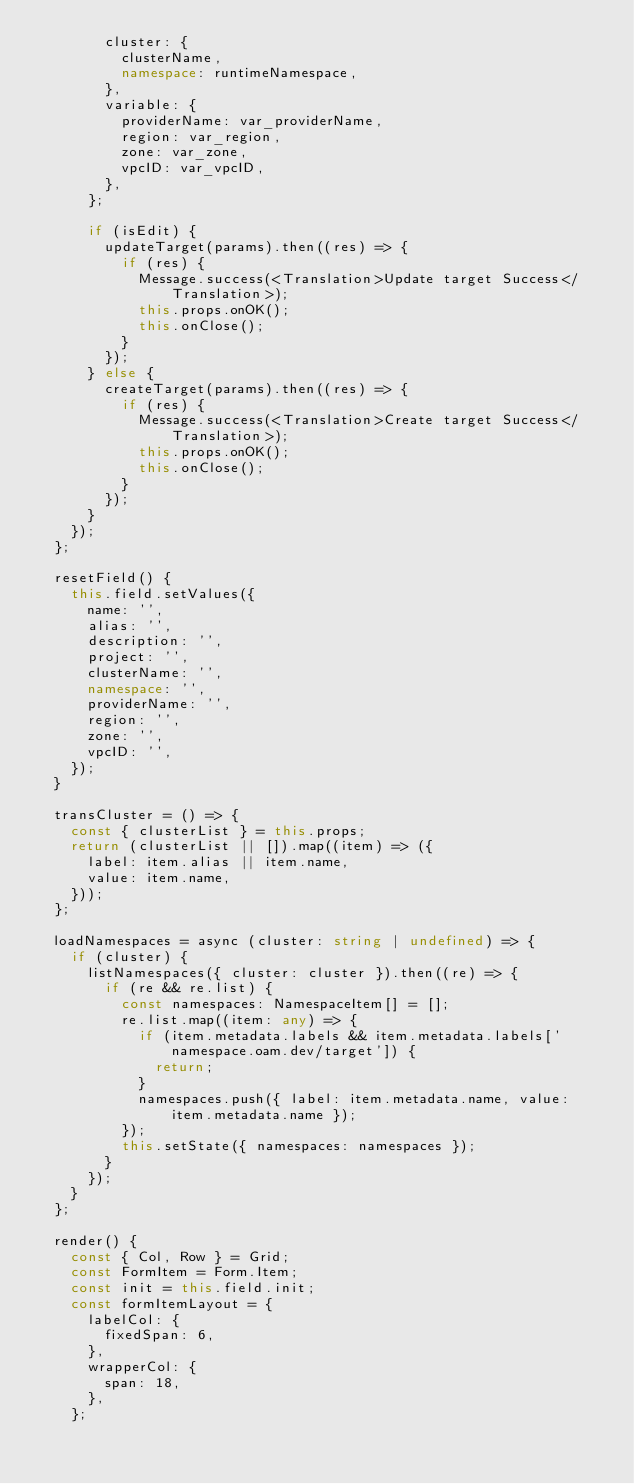Convert code to text. <code><loc_0><loc_0><loc_500><loc_500><_TypeScript_>        cluster: {
          clusterName,
          namespace: runtimeNamespace,
        },
        variable: {
          providerName: var_providerName,
          region: var_region,
          zone: var_zone,
          vpcID: var_vpcID,
        },
      };

      if (isEdit) {
        updateTarget(params).then((res) => {
          if (res) {
            Message.success(<Translation>Update target Success</Translation>);
            this.props.onOK();
            this.onClose();
          }
        });
      } else {
        createTarget(params).then((res) => {
          if (res) {
            Message.success(<Translation>Create target Success</Translation>);
            this.props.onOK();
            this.onClose();
          }
        });
      }
    });
  };

  resetField() {
    this.field.setValues({
      name: '',
      alias: '',
      description: '',
      project: '',
      clusterName: '',
      namespace: '',
      providerName: '',
      region: '',
      zone: '',
      vpcID: '',
    });
  }

  transCluster = () => {
    const { clusterList } = this.props;
    return (clusterList || []).map((item) => ({
      label: item.alias || item.name,
      value: item.name,
    }));
  };

  loadNamespaces = async (cluster: string | undefined) => {
    if (cluster) {
      listNamespaces({ cluster: cluster }).then((re) => {
        if (re && re.list) {
          const namespaces: NamespaceItem[] = [];
          re.list.map((item: any) => {
            if (item.metadata.labels && item.metadata.labels['namespace.oam.dev/target']) {
              return;
            }
            namespaces.push({ label: item.metadata.name, value: item.metadata.name });
          });
          this.setState({ namespaces: namespaces });
        }
      });
    }
  };

  render() {
    const { Col, Row } = Grid;
    const FormItem = Form.Item;
    const init = this.field.init;
    const formItemLayout = {
      labelCol: {
        fixedSpan: 6,
      },
      wrapperCol: {
        span: 18,
      },
    };
</code> 